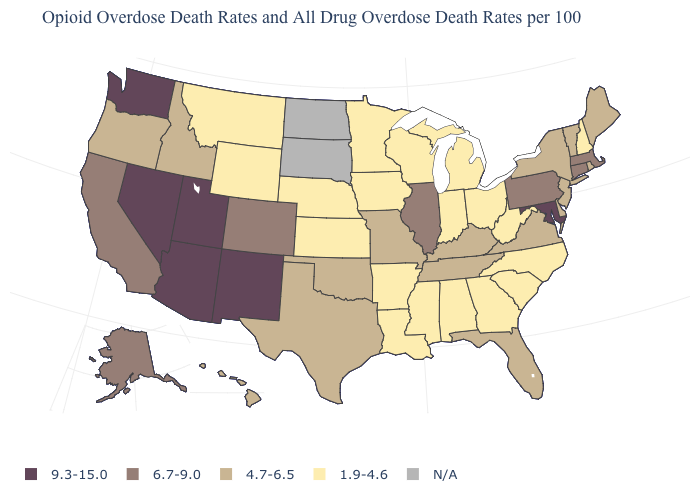Which states have the lowest value in the West?
Quick response, please. Montana, Wyoming. Name the states that have a value in the range 4.7-6.5?
Keep it brief. Delaware, Florida, Hawaii, Idaho, Kentucky, Maine, Missouri, New Jersey, New York, Oklahoma, Oregon, Rhode Island, Tennessee, Texas, Vermont, Virginia. What is the value of Maryland?
Answer briefly. 9.3-15.0. Among the states that border New York , which have the lowest value?
Be succinct. New Jersey, Vermont. Name the states that have a value in the range 6.7-9.0?
Quick response, please. Alaska, California, Colorado, Connecticut, Illinois, Massachusetts, Pennsylvania. Is the legend a continuous bar?
Answer briefly. No. What is the lowest value in states that border Texas?
Give a very brief answer. 1.9-4.6. Which states have the highest value in the USA?
Quick response, please. Arizona, Maryland, Nevada, New Mexico, Utah, Washington. Name the states that have a value in the range 4.7-6.5?
Answer briefly. Delaware, Florida, Hawaii, Idaho, Kentucky, Maine, Missouri, New Jersey, New York, Oklahoma, Oregon, Rhode Island, Tennessee, Texas, Vermont, Virginia. Name the states that have a value in the range 4.7-6.5?
Quick response, please. Delaware, Florida, Hawaii, Idaho, Kentucky, Maine, Missouri, New Jersey, New York, Oklahoma, Oregon, Rhode Island, Tennessee, Texas, Vermont, Virginia. What is the value of South Carolina?
Be succinct. 1.9-4.6. What is the value of Hawaii?
Quick response, please. 4.7-6.5. Which states have the lowest value in the USA?
Give a very brief answer. Alabama, Arkansas, Georgia, Indiana, Iowa, Kansas, Louisiana, Michigan, Minnesota, Mississippi, Montana, Nebraska, New Hampshire, North Carolina, Ohio, South Carolina, West Virginia, Wisconsin, Wyoming. 